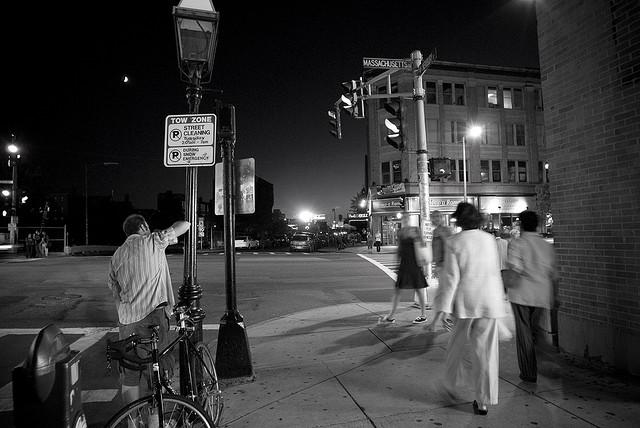How many people are in the picture?
Answer briefly. 5. Are people crossing the street?
Answer briefly. No. Is the photo colored?
Short answer required. No. 